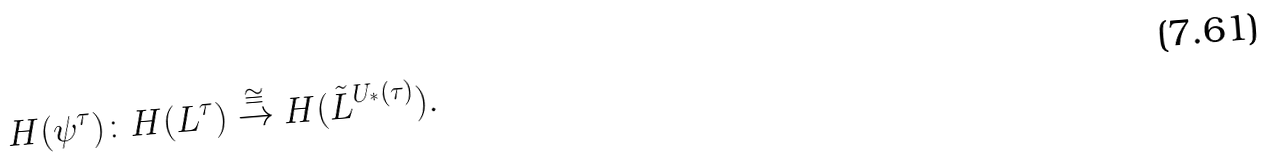Convert formula to latex. <formula><loc_0><loc_0><loc_500><loc_500>H ( \psi ^ { \tau } ) \colon H ( L ^ { \tau } ) \stackrel { \cong } { \rightarrow } H ( \tilde { L } ^ { U _ { ^ { * } } ( \tau ) } ) .</formula> 